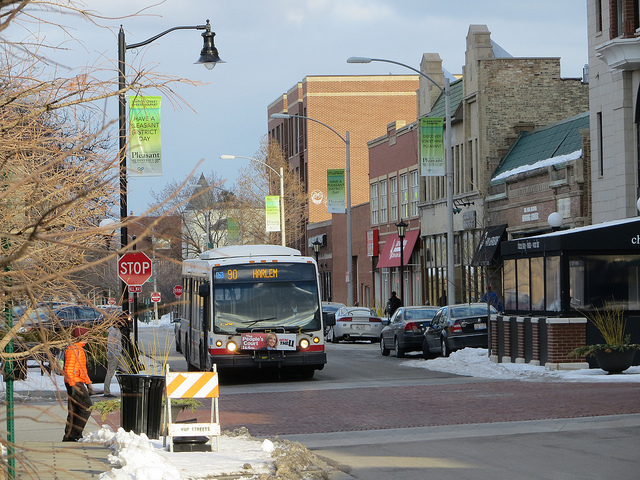<image>What is spelled under ML? I don't know what is spelled under ML. It could be 'stop', '90', 'tertiary', 'harlem', 'nothing' or others. What is spelled under ML? I am not sure what is spelled under ML. It can be seen as 'stop', '90', 'nothing', 'tertiary', or 'harlem'. 